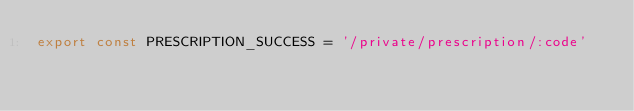Convert code to text. <code><loc_0><loc_0><loc_500><loc_500><_JavaScript_>export const PRESCRIPTION_SUCCESS = '/private/prescription/:code'
</code> 